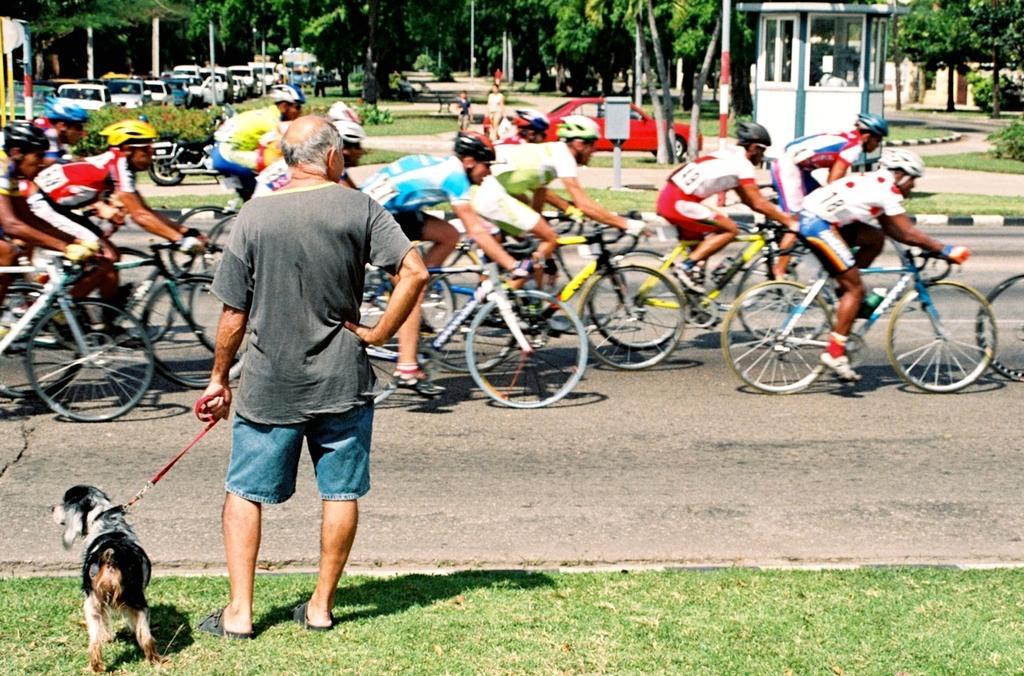How would you summarize this image in a sentence or two? the picture contains the person is holding the dog and he is standing on the grassy land in front of the person there are many people they are riding the bicycle and behind the persons the car is parked and some trees are there and on the left side there are many cars are parked the background is greenery. 